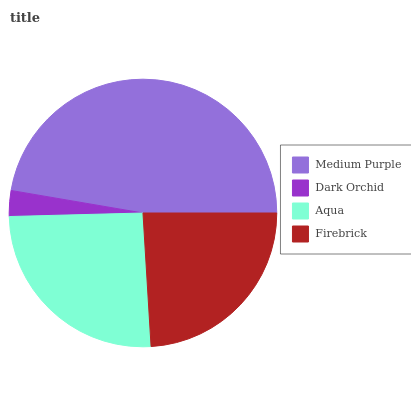Is Dark Orchid the minimum?
Answer yes or no. Yes. Is Medium Purple the maximum?
Answer yes or no. Yes. Is Aqua the minimum?
Answer yes or no. No. Is Aqua the maximum?
Answer yes or no. No. Is Aqua greater than Dark Orchid?
Answer yes or no. Yes. Is Dark Orchid less than Aqua?
Answer yes or no. Yes. Is Dark Orchid greater than Aqua?
Answer yes or no. No. Is Aqua less than Dark Orchid?
Answer yes or no. No. Is Aqua the high median?
Answer yes or no. Yes. Is Firebrick the low median?
Answer yes or no. Yes. Is Medium Purple the high median?
Answer yes or no. No. Is Medium Purple the low median?
Answer yes or no. No. 